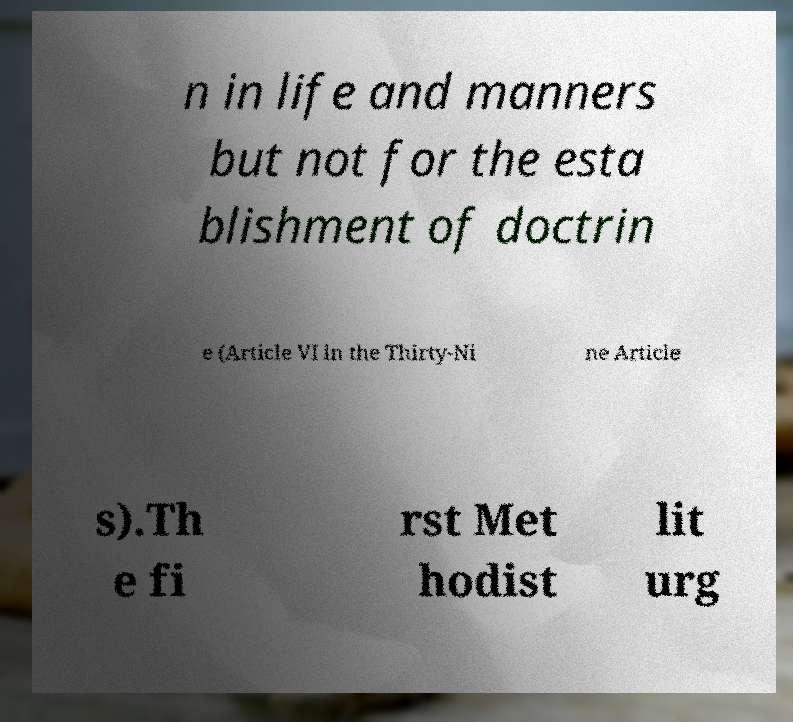Could you assist in decoding the text presented in this image and type it out clearly? n in life and manners but not for the esta blishment of doctrin e (Article VI in the Thirty-Ni ne Article s).Th e fi rst Met hodist lit urg 